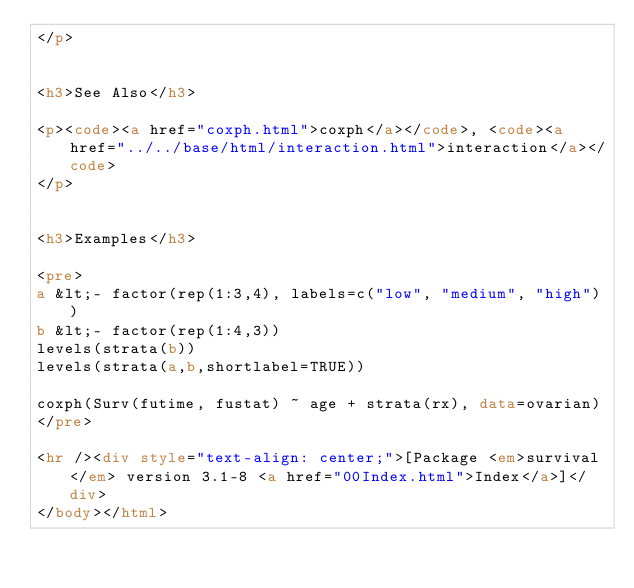<code> <loc_0><loc_0><loc_500><loc_500><_HTML_></p>


<h3>See Also</h3>

<p><code><a href="coxph.html">coxph</a></code>, <code><a href="../../base/html/interaction.html">interaction</a></code>
</p>


<h3>Examples</h3>

<pre>
a &lt;- factor(rep(1:3,4), labels=c("low", "medium", "high"))
b &lt;- factor(rep(1:4,3))
levels(strata(b))
levels(strata(a,b,shortlabel=TRUE))

coxph(Surv(futime, fustat) ~ age + strata(rx), data=ovarian) 
</pre>

<hr /><div style="text-align: center;">[Package <em>survival</em> version 3.1-8 <a href="00Index.html">Index</a>]</div>
</body></html>
</code> 